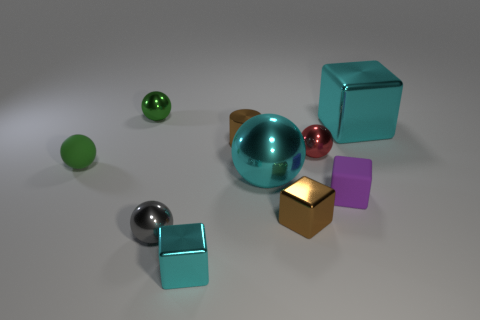Subtract all gray cylinders. Subtract all gray blocks. How many cylinders are left? 1 Subtract all cubes. How many objects are left? 6 Subtract all tiny brown cubes. Subtract all gray shiny balls. How many objects are left? 8 Add 7 brown metallic cylinders. How many brown metallic cylinders are left? 8 Add 4 green objects. How many green objects exist? 6 Subtract 0 gray blocks. How many objects are left? 10 